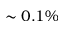<formula> <loc_0><loc_0><loc_500><loc_500>\sim 0 . 1 \%</formula> 